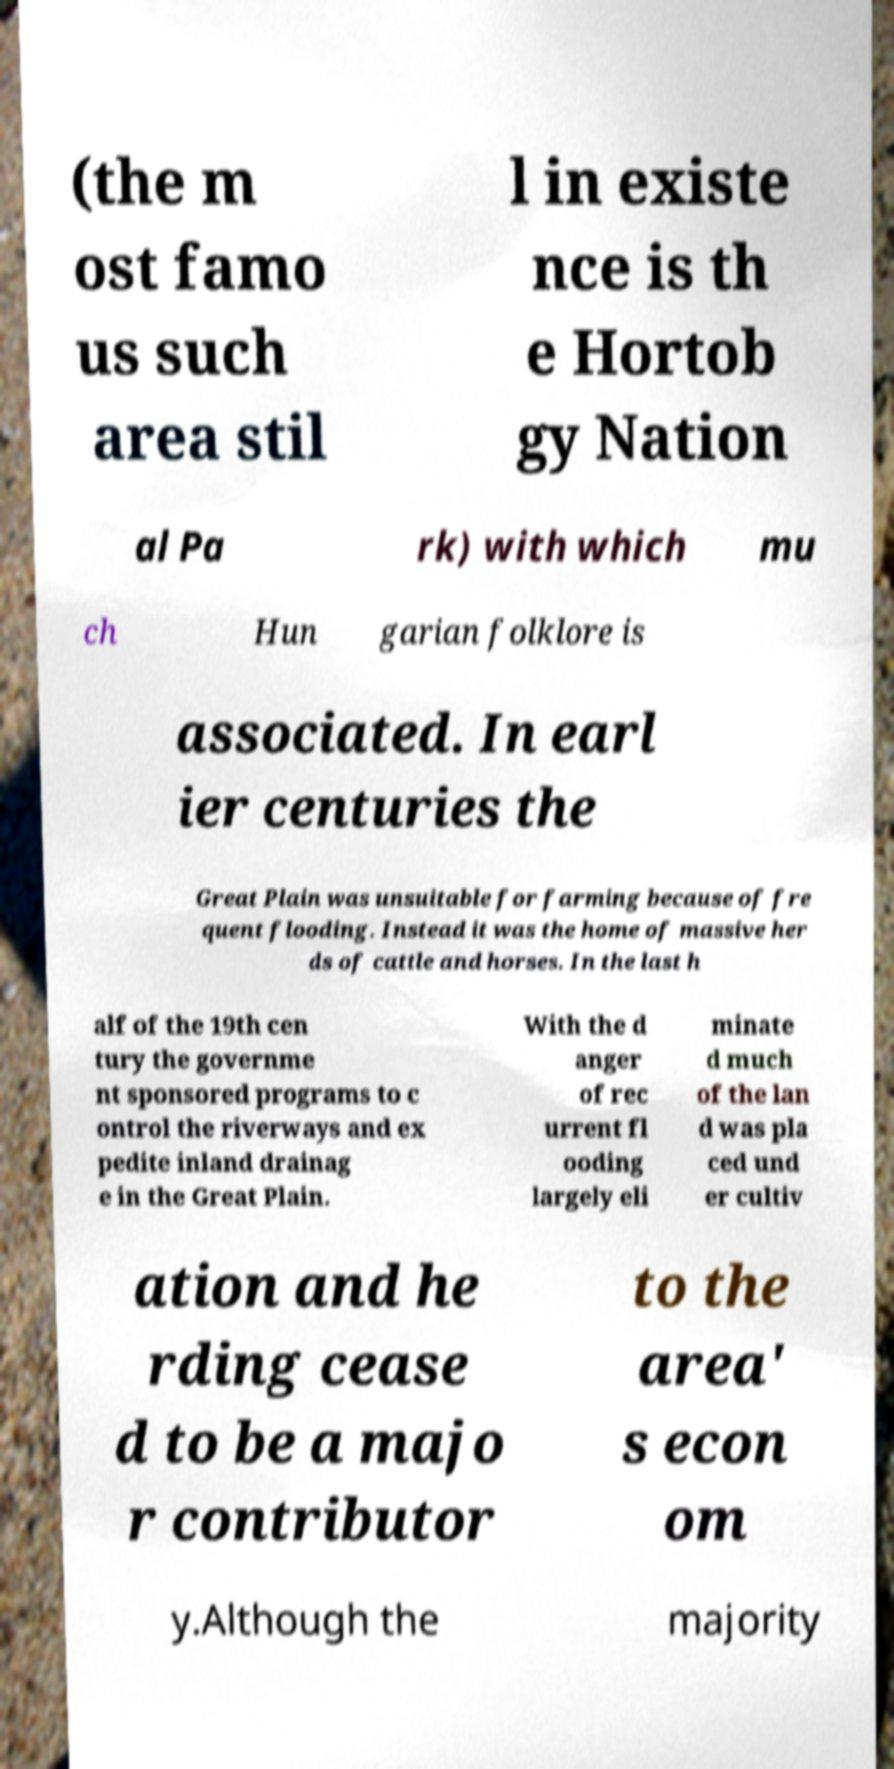Please read and relay the text visible in this image. What does it say? (the m ost famo us such area stil l in existe nce is th e Hortob gy Nation al Pa rk) with which mu ch Hun garian folklore is associated. In earl ier centuries the Great Plain was unsuitable for farming because of fre quent flooding. Instead it was the home of massive her ds of cattle and horses. In the last h alf of the 19th cen tury the governme nt sponsored programs to c ontrol the riverways and ex pedite inland drainag e in the Great Plain. With the d anger of rec urrent fl ooding largely eli minate d much of the lan d was pla ced und er cultiv ation and he rding cease d to be a majo r contributor to the area' s econ om y.Although the majority 